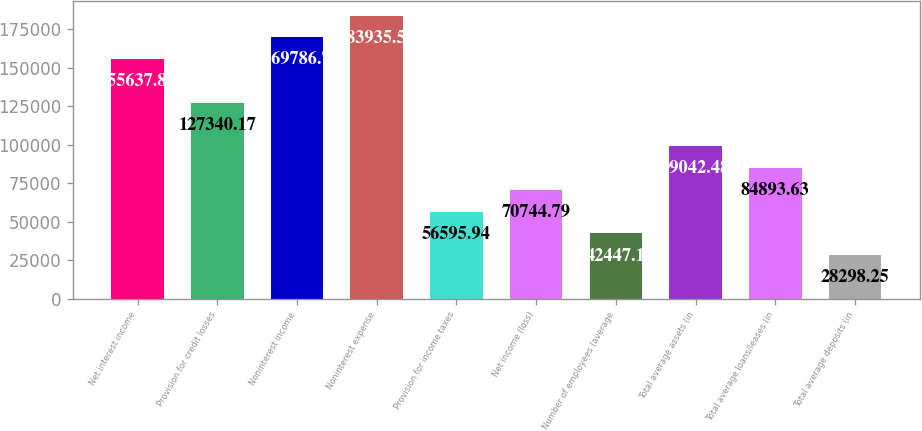Convert chart. <chart><loc_0><loc_0><loc_500><loc_500><bar_chart><fcel>Net interest income<fcel>Provision for credit losses<fcel>Noninterest income<fcel>Noninterest expense<fcel>Provision for income taxes<fcel>Net income (loss)<fcel>Number of employees (average<fcel>Total average assets (in<fcel>Total average loans/leases (in<fcel>Total average deposits (in<nl><fcel>155638<fcel>127340<fcel>169787<fcel>183936<fcel>56595.9<fcel>70744.8<fcel>42447.1<fcel>99042.5<fcel>84893.6<fcel>28298.2<nl></chart> 